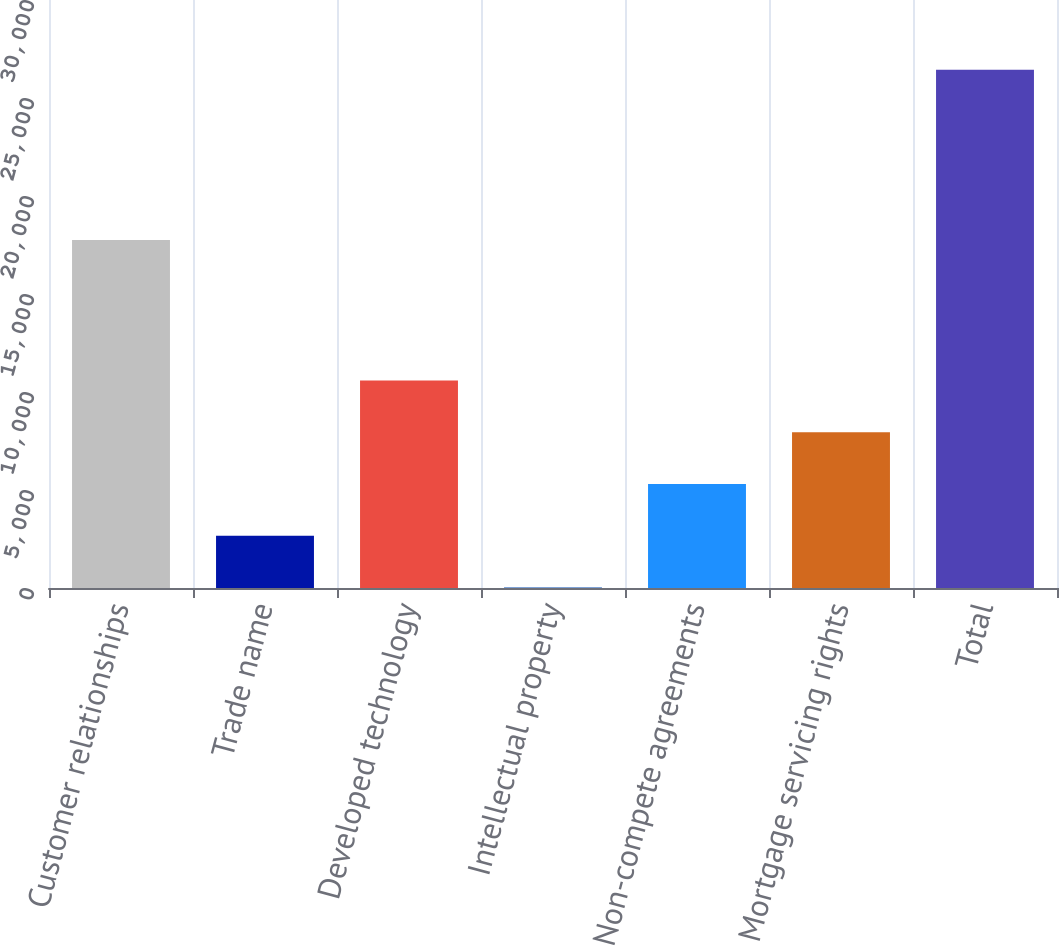Convert chart. <chart><loc_0><loc_0><loc_500><loc_500><bar_chart><fcel>Customer relationships<fcel>Trade name<fcel>Developed technology<fcel>Intellectual property<fcel>Non-compete agreements<fcel>Mortgage servicing rights<fcel>Total<nl><fcel>17759<fcel>2665.1<fcel>10591.4<fcel>23<fcel>5307.2<fcel>7949.3<fcel>26444<nl></chart> 